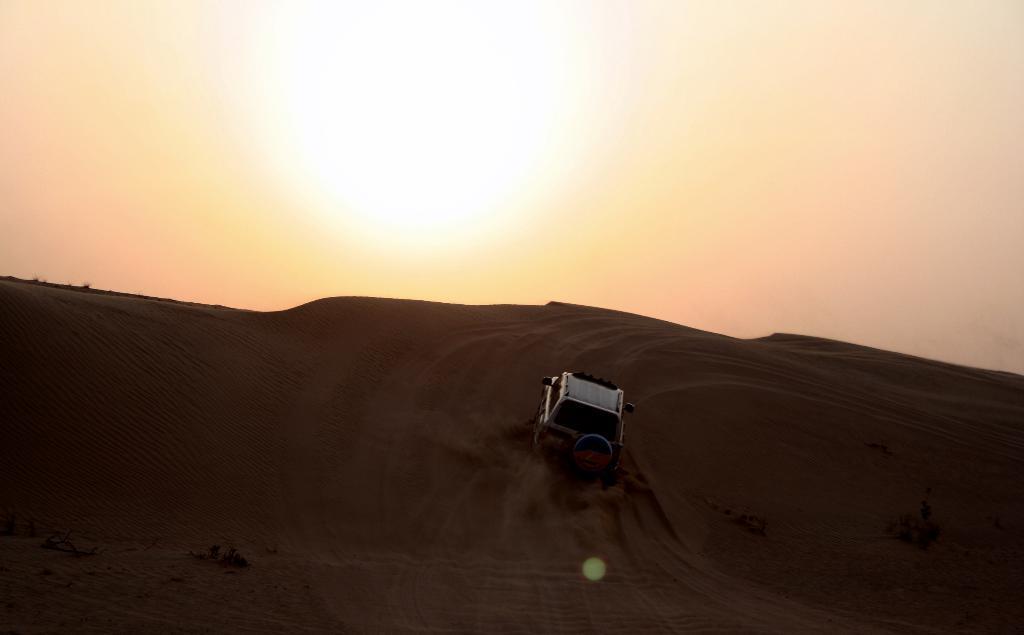How would you summarize this image in a sentence or two? In the image we can see a vehicle, sand, sky, plant and the sun. 